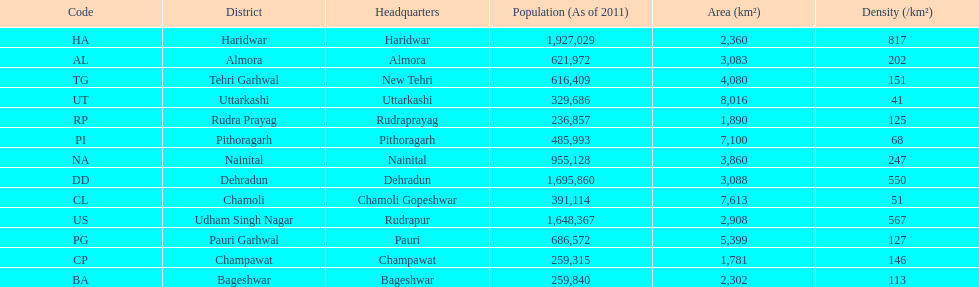I'm looking to parse the entire table for insights. Could you assist me with that? {'header': ['Code', 'District', 'Headquarters', 'Population (As of 2011)', 'Area (km²)', 'Density (/km²)'], 'rows': [['HA', 'Haridwar', 'Haridwar', '1,927,029', '2,360', '817'], ['AL', 'Almora', 'Almora', '621,972', '3,083', '202'], ['TG', 'Tehri Garhwal', 'New Tehri', '616,409', '4,080', '151'], ['UT', 'Uttarkashi', 'Uttarkashi', '329,686', '8,016', '41'], ['RP', 'Rudra Prayag', 'Rudraprayag', '236,857', '1,890', '125'], ['PI', 'Pithoragarh', 'Pithoragarh', '485,993', '7,100', '68'], ['NA', 'Nainital', 'Nainital', '955,128', '3,860', '247'], ['DD', 'Dehradun', 'Dehradun', '1,695,860', '3,088', '550'], ['CL', 'Chamoli', 'Chamoli Gopeshwar', '391,114', '7,613', '51'], ['US', 'Udham Singh Nagar', 'Rudrapur', '1,648,367', '2,908', '567'], ['PG', 'Pauri Garhwal', 'Pauri', '686,572', '5,399', '127'], ['CP', 'Champawat', 'Champawat', '259,315', '1,781', '146'], ['BA', 'Bageshwar', 'Bageshwar', '259,840', '2,302', '113']]} Which headquarter has the same district name but has a density of 202? Almora. 